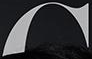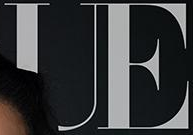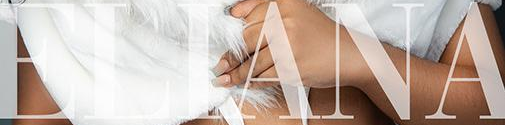Identify the words shown in these images in order, separated by a semicolon. #; UE; ELIANA 